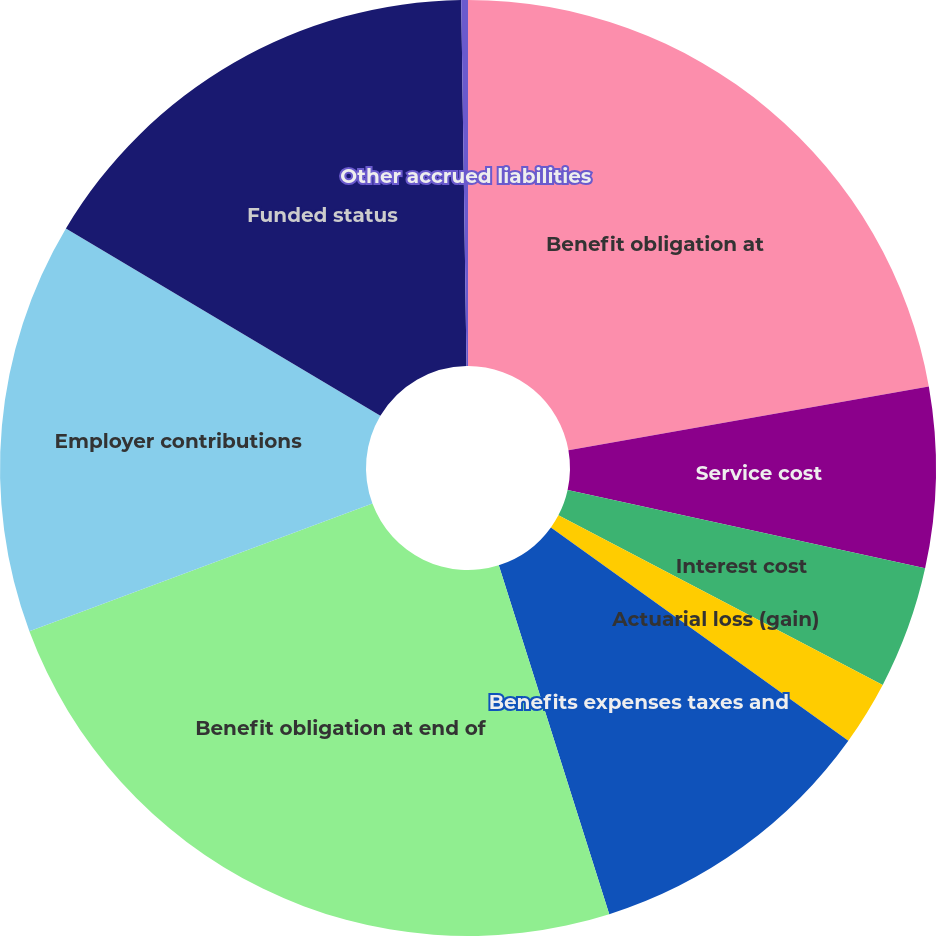<chart> <loc_0><loc_0><loc_500><loc_500><pie_chart><fcel>Benefit obligation at<fcel>Service cost<fcel>Interest cost<fcel>Actuarial loss (gain)<fcel>Benefits expenses taxes and<fcel>Benefit obligation at end of<fcel>Employer contributions<fcel>Funded status<fcel>Other accrued liabilities<nl><fcel>22.21%<fcel>6.23%<fcel>4.23%<fcel>2.23%<fcel>10.22%<fcel>24.21%<fcel>14.22%<fcel>16.22%<fcel>0.23%<nl></chart> 